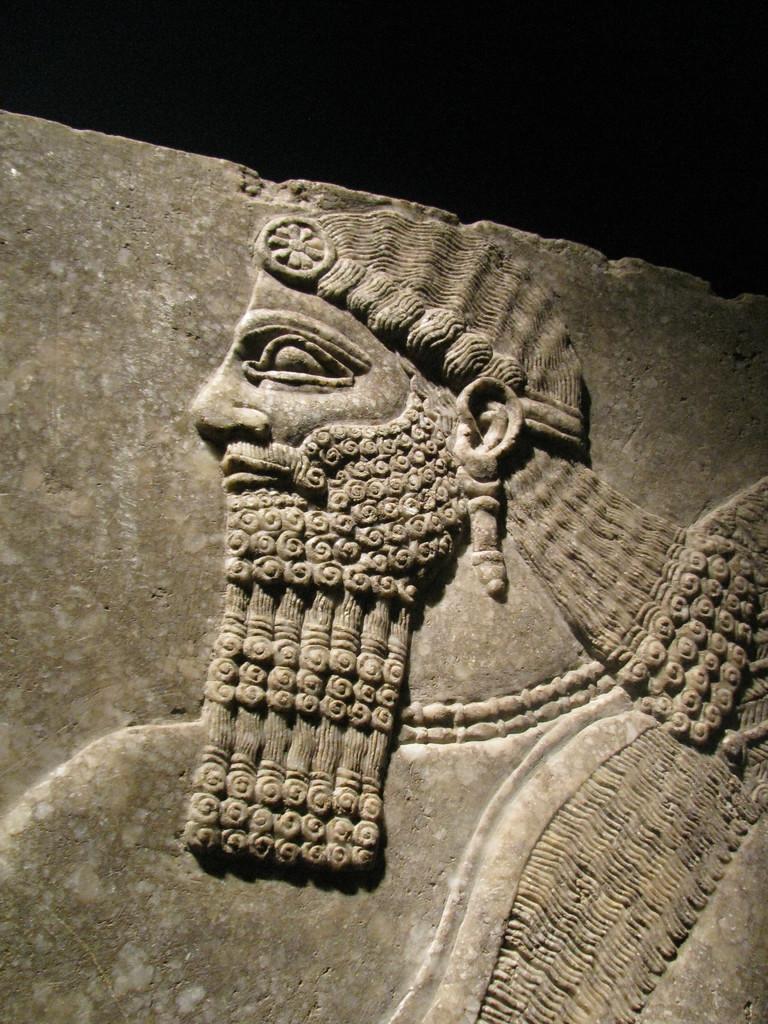Can you describe this image briefly? In this image there is carving of a person on the stone. 